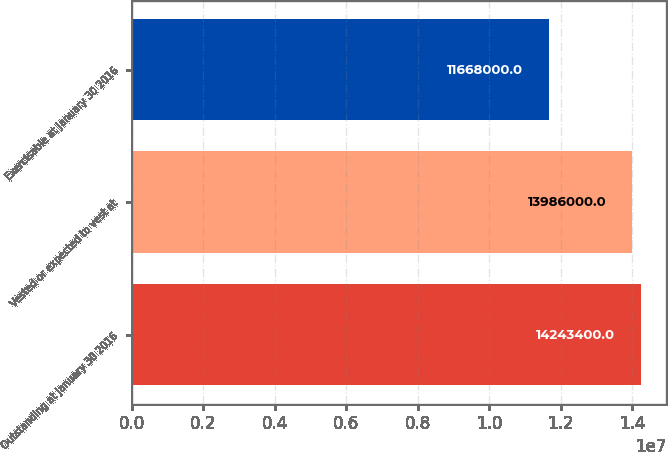<chart> <loc_0><loc_0><loc_500><loc_500><bar_chart><fcel>Outstanding at January 30 2016<fcel>Vested or expected to vest at<fcel>Exercisable at January 30 2016<nl><fcel>1.42434e+07<fcel>1.3986e+07<fcel>1.1668e+07<nl></chart> 